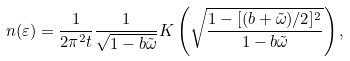Convert formula to latex. <formula><loc_0><loc_0><loc_500><loc_500>n ( \varepsilon ) = \frac { 1 } { 2 \pi ^ { 2 } t } \frac { 1 } { \sqrt { 1 - b \tilde { \omega } } } { K } \left ( \sqrt { \frac { 1 - [ ( b + \tilde { \omega } ) / 2 ] ^ { 2 } } { 1 - b \tilde { \omega } } } \right ) ,</formula> 